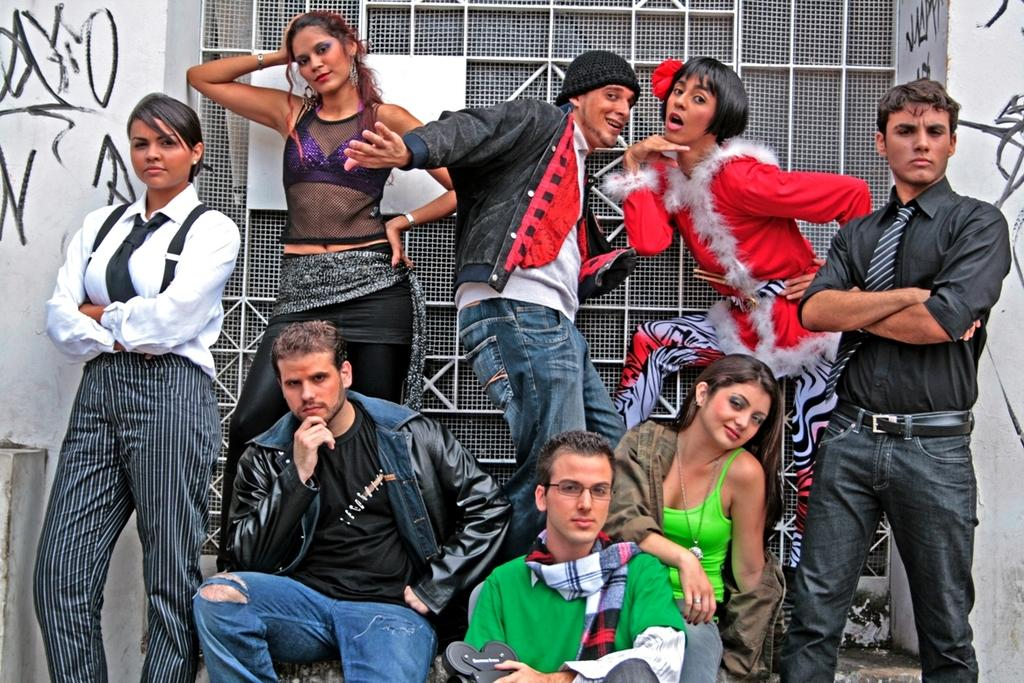How many people are in the image? There is a group of people in the image. What can be observed about the clothing of the people in the image? The people are wearing different color dresses. What is visible in the background of the image? There is a white wall and a net window in the background of the image. What type of connection can be seen between the people in the image? There is no specific connection visible between the people in the image; they are simply standing together. What stage of development is the flock of birds in the image? There are no birds present in the image, so it is not possible to determine the stage of development of any flock. 